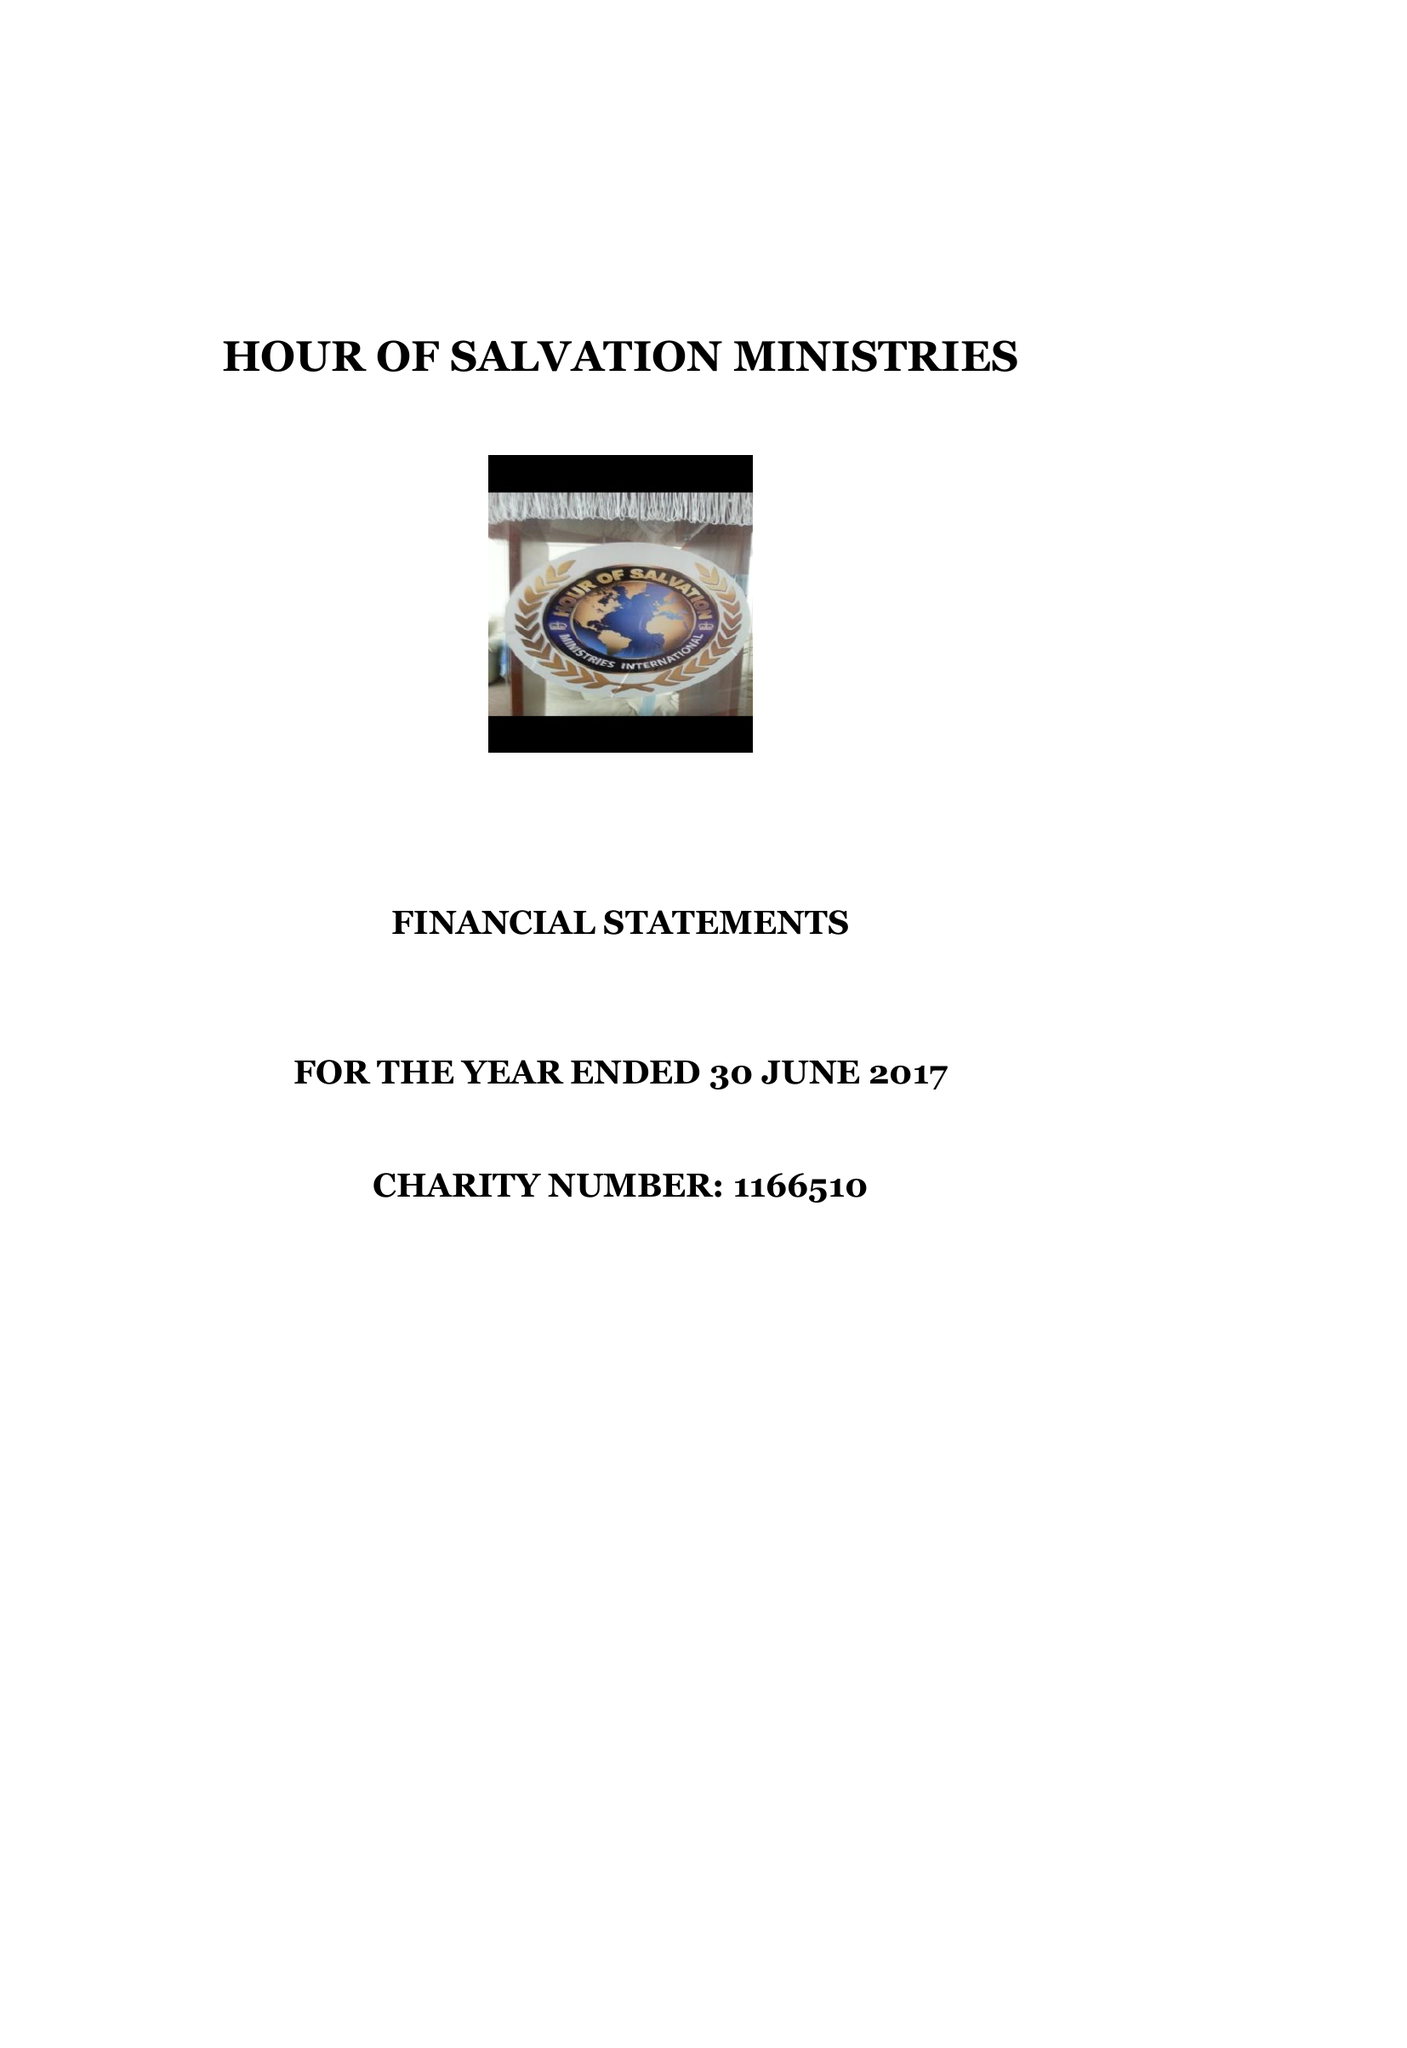What is the value for the charity_name?
Answer the question using a single word or phrase. Hour Of Salvation Ministries 